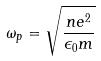<formula> <loc_0><loc_0><loc_500><loc_500>\omega _ { p } = \sqrt { \frac { n e ^ { 2 } } { \epsilon _ { 0 } m } }</formula> 